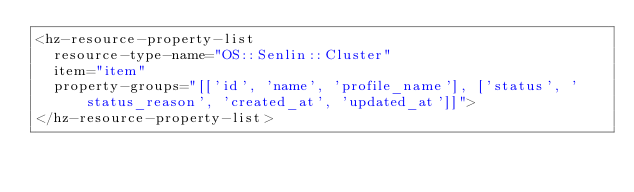Convert code to text. <code><loc_0><loc_0><loc_500><loc_500><_HTML_><hz-resource-property-list
  resource-type-name="OS::Senlin::Cluster"
  item="item"
  property-groups="[['id', 'name', 'profile_name'], ['status', 'status_reason', 'created_at', 'updated_at']]">
</hz-resource-property-list>
</code> 